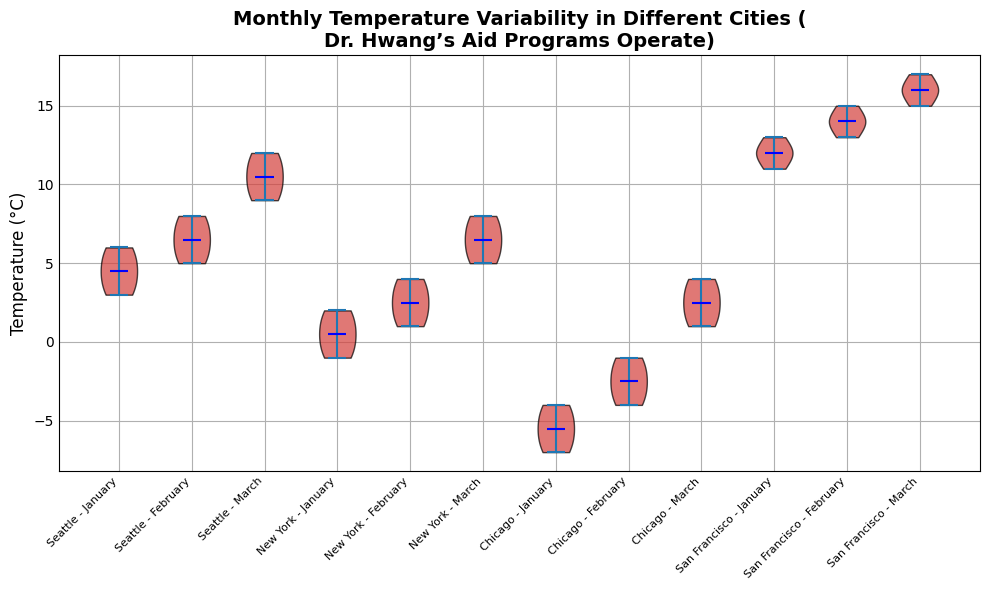What city has the highest temperature in March? The highest temperature can be seen in the topmost part of the violin plots for March. By looking at the height, San Francisco's March data reach 17°C, which is higher than the other cities.
Answer: San Francisco What's the range of temperatures in Chicago for January? The violin plot for Chicago in January shows the spread from the lowest to the highest point. It ranges from -7°C to -4°C.
Answer: -7°C to -4°C Which city shows the most temperature variability in January? To determine variability, look at the width and spread of the violin plots for all cities in January. The wider and more spread out the plot, the more variability. New York's plot appears to be the widest.
Answer: New York What is the median temperature in Seattle for February? The median is represented by the horizontal line within the violin plots. For Seattle in February, this line is positioned at 7°C.
Answer: 7°C Which city has the least variation in temperatures in February? The least variation is indicated by the narrowest violin plot in February. San Francisco's plot appears the narrowest.
Answer: San Francisco Compare the median temperatures in March between Seattle and Chicago. Look at the horizontal median lines inside the violin plots for March. Seattle has a median of 10.5°C and Chicago has a median of 2.5°C.
Answer: Seattle has a higher median What is the average temperature range in New York between January and March? January: -1°C to 2°C, February: 1°C to 4°C, March: 5°C to 8°C. Calculate the range for each month, then average them: (3 + 3 + 3) / 3 = 3°C.
Answer: 3°C Which month shows the highest median temperature for San Francisco? Look at the median lines for San Francisco across the months. The highest median line is seen in March, at 16°C.
Answer: March What is the difference in median temperatures between February and March in Chicago? The median temperature for Chicago in February is -2.5°C and in March is 2.5°C. The difference is calculated as 2.5 - (-2.5) = 5°C.
Answer: 5°C Which city experienced the lowest recorded temperature across all months? By examining the lowest points of all violin plots, Chicago in January shows the lowest temperature at -7°C.
Answer: Chicago 